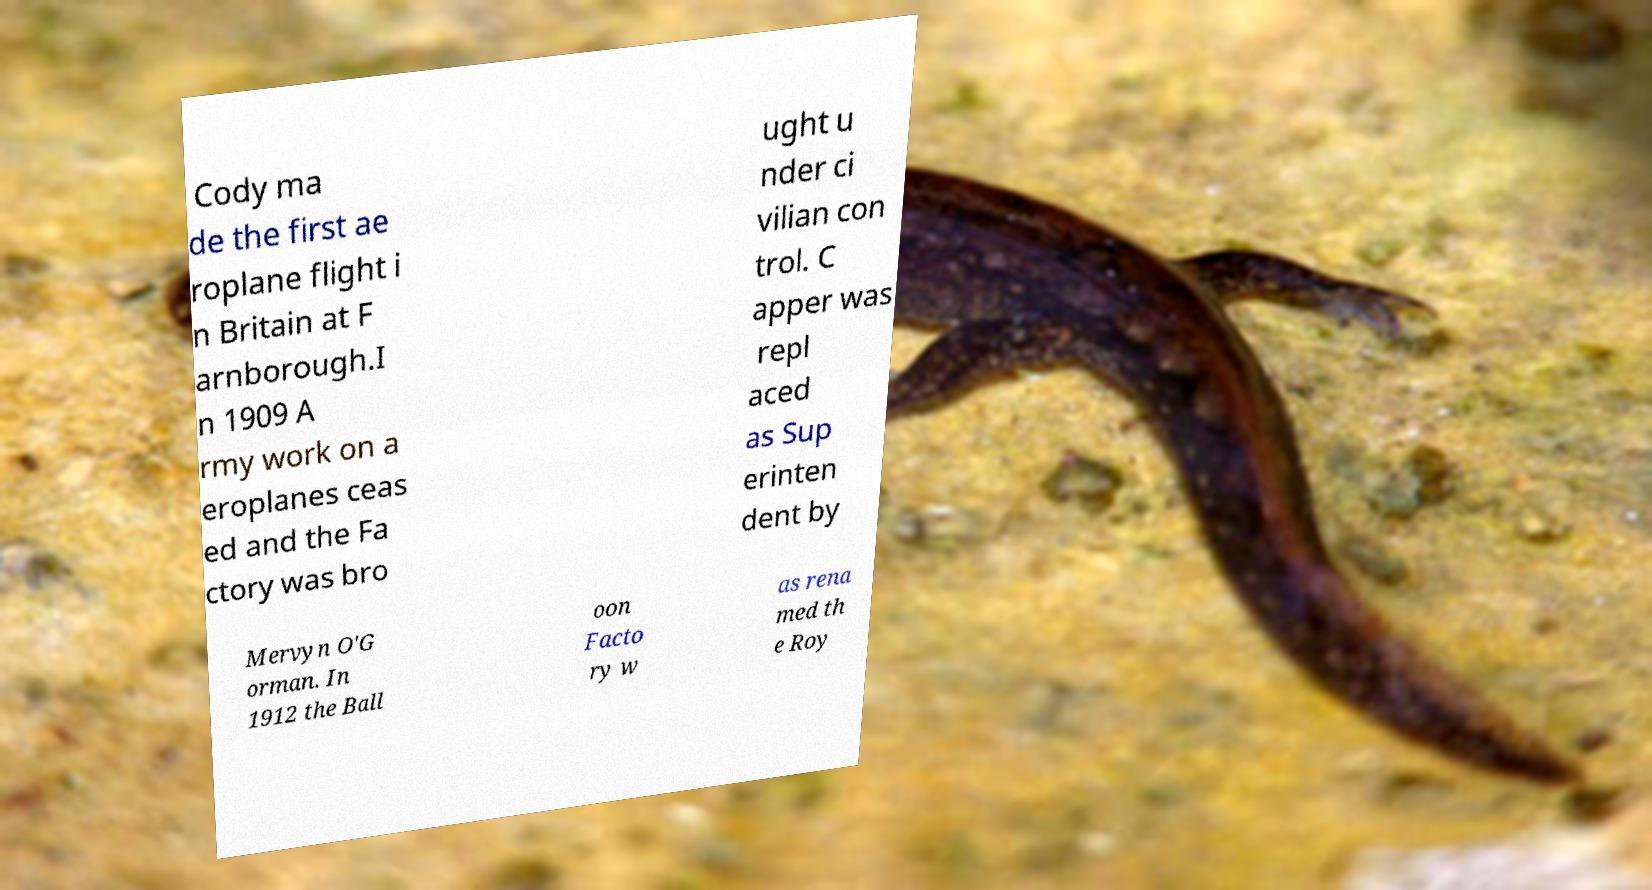Please read and relay the text visible in this image. What does it say? Cody ma de the first ae roplane flight i n Britain at F arnborough.I n 1909 A rmy work on a eroplanes ceas ed and the Fa ctory was bro ught u nder ci vilian con trol. C apper was repl aced as Sup erinten dent by Mervyn O'G orman. In 1912 the Ball oon Facto ry w as rena med th e Roy 